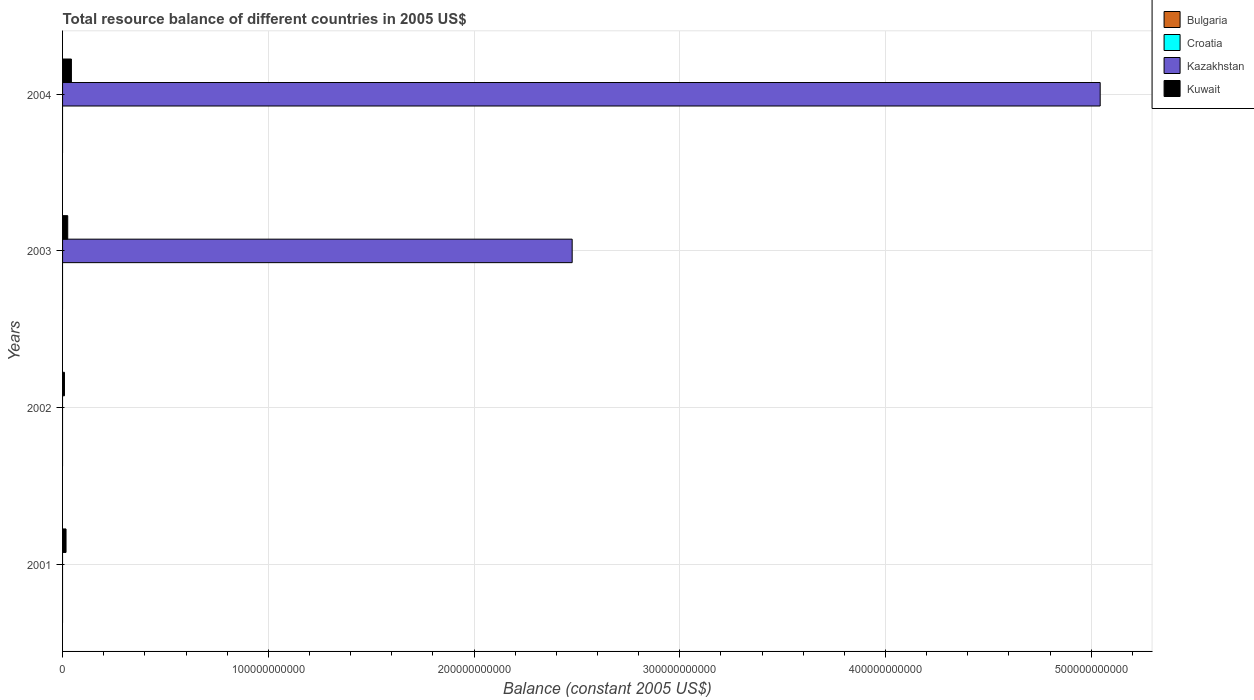Are the number of bars on each tick of the Y-axis equal?
Your answer should be compact. No. What is the label of the 2nd group of bars from the top?
Offer a terse response. 2003. In how many cases, is the number of bars for a given year not equal to the number of legend labels?
Keep it short and to the point. 4. What is the total resource balance in Kuwait in 2002?
Ensure brevity in your answer.  9.28e+08. Across all years, what is the maximum total resource balance in Kuwait?
Provide a succinct answer. 4.30e+09. Across all years, what is the minimum total resource balance in Kazakhstan?
Offer a terse response. 0. In which year was the total resource balance in Kuwait maximum?
Provide a succinct answer. 2004. What is the total total resource balance in Kazakhstan in the graph?
Offer a terse response. 7.52e+11. What is the difference between the total resource balance in Kuwait in 2001 and that in 2004?
Offer a very short reply. -2.61e+09. What is the difference between the total resource balance in Bulgaria in 2003 and the total resource balance in Kazakhstan in 2002?
Make the answer very short. 0. In the year 2003, what is the difference between the total resource balance in Kazakhstan and total resource balance in Kuwait?
Provide a short and direct response. 2.45e+11. In how many years, is the total resource balance in Kuwait greater than 380000000000 US$?
Make the answer very short. 0. What is the ratio of the total resource balance in Kuwait in 2002 to that in 2003?
Offer a very short reply. 0.37. What is the difference between the highest and the lowest total resource balance in Kazakhstan?
Provide a succinct answer. 5.04e+11. In how many years, is the total resource balance in Bulgaria greater than the average total resource balance in Bulgaria taken over all years?
Your response must be concise. 0. Is the sum of the total resource balance in Kuwait in 2003 and 2004 greater than the maximum total resource balance in Croatia across all years?
Give a very brief answer. Yes. Is it the case that in every year, the sum of the total resource balance in Bulgaria and total resource balance in Kuwait is greater than the sum of total resource balance in Croatia and total resource balance in Kazakhstan?
Offer a terse response. No. Is it the case that in every year, the sum of the total resource balance in Kazakhstan and total resource balance in Croatia is greater than the total resource balance in Bulgaria?
Your response must be concise. No. How many bars are there?
Provide a short and direct response. 6. What is the difference between two consecutive major ticks on the X-axis?
Make the answer very short. 1.00e+11. Does the graph contain any zero values?
Give a very brief answer. Yes. Does the graph contain grids?
Provide a succinct answer. Yes. Where does the legend appear in the graph?
Your response must be concise. Top right. How are the legend labels stacked?
Offer a terse response. Vertical. What is the title of the graph?
Offer a very short reply. Total resource balance of different countries in 2005 US$. Does "High income: nonOECD" appear as one of the legend labels in the graph?
Keep it short and to the point. No. What is the label or title of the X-axis?
Keep it short and to the point. Balance (constant 2005 US$). What is the Balance (constant 2005 US$) in Bulgaria in 2001?
Your answer should be very brief. 0. What is the Balance (constant 2005 US$) of Kazakhstan in 2001?
Your answer should be very brief. 0. What is the Balance (constant 2005 US$) in Kuwait in 2001?
Offer a very short reply. 1.69e+09. What is the Balance (constant 2005 US$) in Kuwait in 2002?
Provide a short and direct response. 9.28e+08. What is the Balance (constant 2005 US$) of Kazakhstan in 2003?
Provide a short and direct response. 2.48e+11. What is the Balance (constant 2005 US$) in Kuwait in 2003?
Your answer should be compact. 2.52e+09. What is the Balance (constant 2005 US$) of Croatia in 2004?
Your answer should be very brief. 0. What is the Balance (constant 2005 US$) in Kazakhstan in 2004?
Provide a short and direct response. 5.04e+11. What is the Balance (constant 2005 US$) of Kuwait in 2004?
Provide a short and direct response. 4.30e+09. Across all years, what is the maximum Balance (constant 2005 US$) in Kazakhstan?
Give a very brief answer. 5.04e+11. Across all years, what is the maximum Balance (constant 2005 US$) in Kuwait?
Your answer should be very brief. 4.30e+09. Across all years, what is the minimum Balance (constant 2005 US$) of Kuwait?
Make the answer very short. 9.28e+08. What is the total Balance (constant 2005 US$) in Croatia in the graph?
Provide a short and direct response. 0. What is the total Balance (constant 2005 US$) in Kazakhstan in the graph?
Your response must be concise. 7.52e+11. What is the total Balance (constant 2005 US$) of Kuwait in the graph?
Ensure brevity in your answer.  9.43e+09. What is the difference between the Balance (constant 2005 US$) in Kuwait in 2001 and that in 2002?
Provide a succinct answer. 7.59e+08. What is the difference between the Balance (constant 2005 US$) in Kuwait in 2001 and that in 2003?
Provide a succinct answer. -8.28e+08. What is the difference between the Balance (constant 2005 US$) in Kuwait in 2001 and that in 2004?
Ensure brevity in your answer.  -2.61e+09. What is the difference between the Balance (constant 2005 US$) of Kuwait in 2002 and that in 2003?
Ensure brevity in your answer.  -1.59e+09. What is the difference between the Balance (constant 2005 US$) of Kuwait in 2002 and that in 2004?
Your answer should be compact. -3.37e+09. What is the difference between the Balance (constant 2005 US$) in Kazakhstan in 2003 and that in 2004?
Make the answer very short. -2.57e+11. What is the difference between the Balance (constant 2005 US$) of Kuwait in 2003 and that in 2004?
Offer a terse response. -1.78e+09. What is the difference between the Balance (constant 2005 US$) of Kazakhstan in 2003 and the Balance (constant 2005 US$) of Kuwait in 2004?
Give a very brief answer. 2.43e+11. What is the average Balance (constant 2005 US$) in Bulgaria per year?
Ensure brevity in your answer.  0. What is the average Balance (constant 2005 US$) in Kazakhstan per year?
Your response must be concise. 1.88e+11. What is the average Balance (constant 2005 US$) in Kuwait per year?
Provide a short and direct response. 2.36e+09. In the year 2003, what is the difference between the Balance (constant 2005 US$) in Kazakhstan and Balance (constant 2005 US$) in Kuwait?
Your answer should be very brief. 2.45e+11. In the year 2004, what is the difference between the Balance (constant 2005 US$) of Kazakhstan and Balance (constant 2005 US$) of Kuwait?
Your answer should be very brief. 5.00e+11. What is the ratio of the Balance (constant 2005 US$) of Kuwait in 2001 to that in 2002?
Offer a terse response. 1.82. What is the ratio of the Balance (constant 2005 US$) in Kuwait in 2001 to that in 2003?
Your answer should be very brief. 0.67. What is the ratio of the Balance (constant 2005 US$) in Kuwait in 2001 to that in 2004?
Offer a terse response. 0.39. What is the ratio of the Balance (constant 2005 US$) in Kuwait in 2002 to that in 2003?
Ensure brevity in your answer.  0.37. What is the ratio of the Balance (constant 2005 US$) in Kuwait in 2002 to that in 2004?
Provide a succinct answer. 0.22. What is the ratio of the Balance (constant 2005 US$) in Kazakhstan in 2003 to that in 2004?
Keep it short and to the point. 0.49. What is the ratio of the Balance (constant 2005 US$) in Kuwait in 2003 to that in 2004?
Your answer should be very brief. 0.59. What is the difference between the highest and the second highest Balance (constant 2005 US$) in Kuwait?
Offer a terse response. 1.78e+09. What is the difference between the highest and the lowest Balance (constant 2005 US$) of Kazakhstan?
Offer a very short reply. 5.04e+11. What is the difference between the highest and the lowest Balance (constant 2005 US$) of Kuwait?
Offer a terse response. 3.37e+09. 